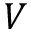Convert formula to latex. <formula><loc_0><loc_0><loc_500><loc_500>V</formula> 